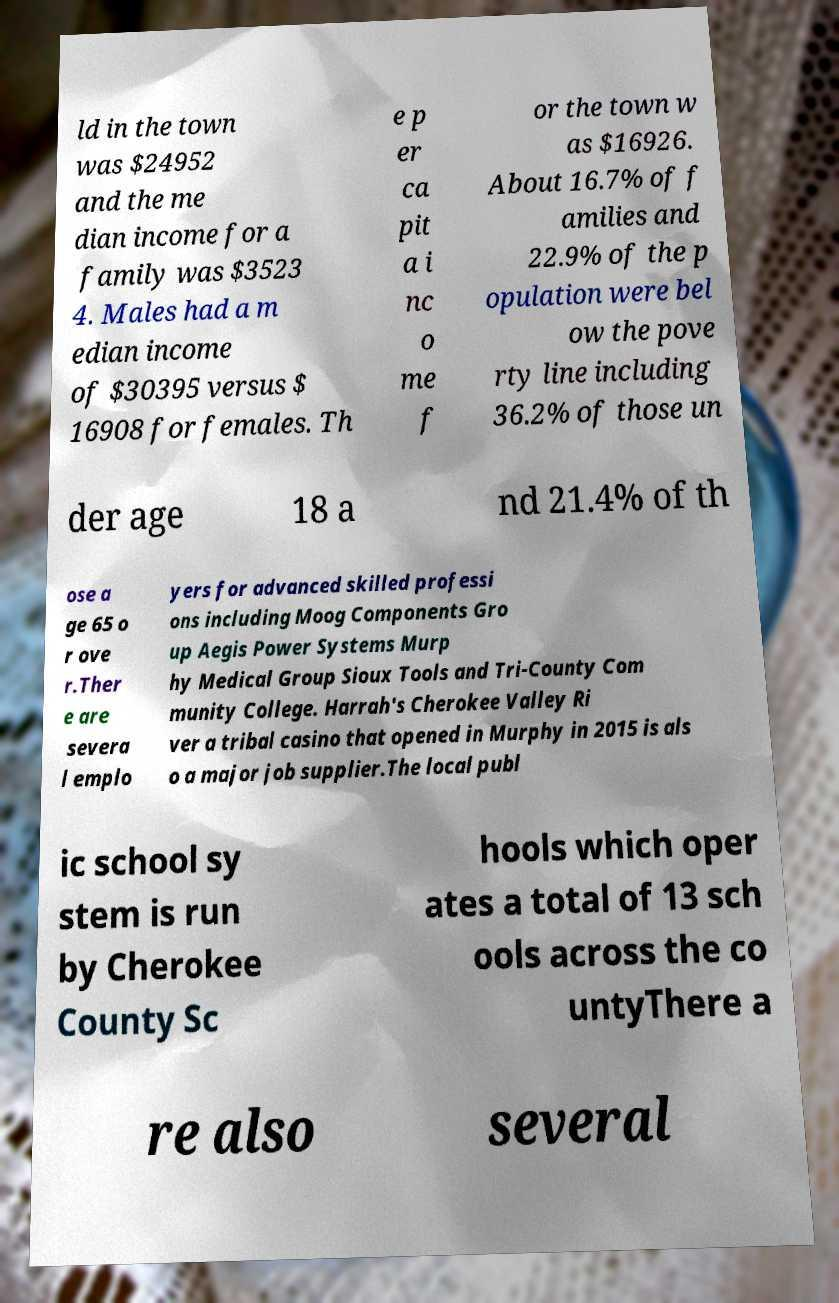Can you read and provide the text displayed in the image?This photo seems to have some interesting text. Can you extract and type it out for me? ld in the town was $24952 and the me dian income for a family was $3523 4. Males had a m edian income of $30395 versus $ 16908 for females. Th e p er ca pit a i nc o me f or the town w as $16926. About 16.7% of f amilies and 22.9% of the p opulation were bel ow the pove rty line including 36.2% of those un der age 18 a nd 21.4% of th ose a ge 65 o r ove r.Ther e are severa l emplo yers for advanced skilled professi ons including Moog Components Gro up Aegis Power Systems Murp hy Medical Group Sioux Tools and Tri-County Com munity College. Harrah's Cherokee Valley Ri ver a tribal casino that opened in Murphy in 2015 is als o a major job supplier.The local publ ic school sy stem is run by Cherokee County Sc hools which oper ates a total of 13 sch ools across the co untyThere a re also several 